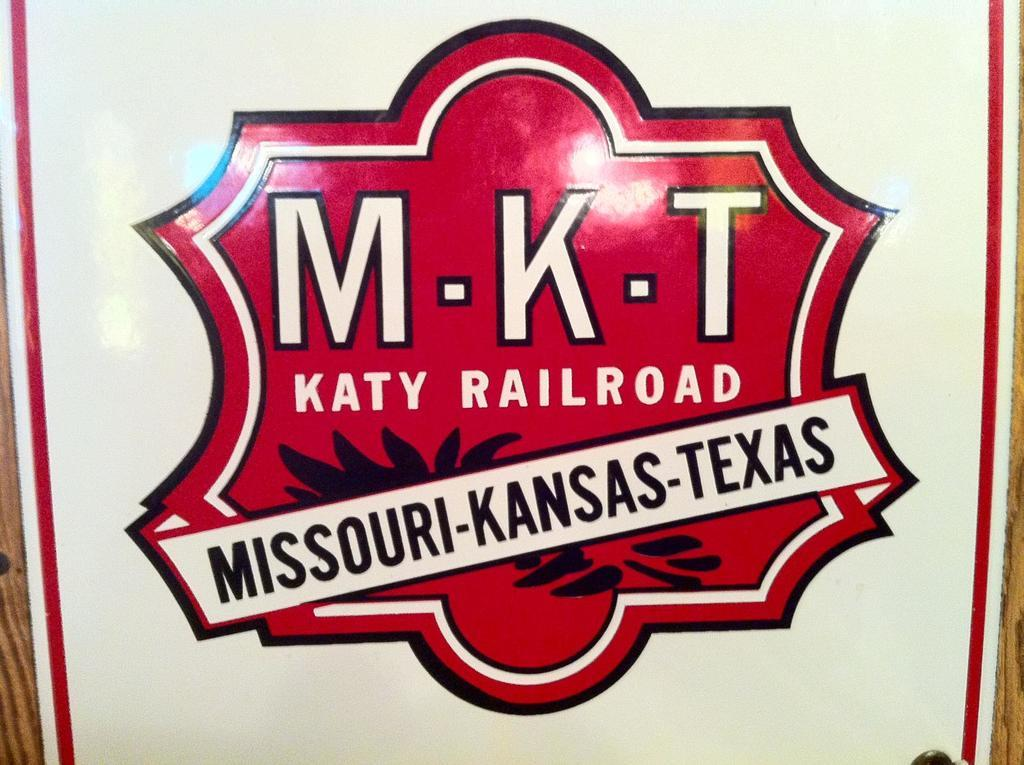<image>
Describe the image concisely. A red crest has MKT Katy Railroad for Missouri, Kansas and Texas. 